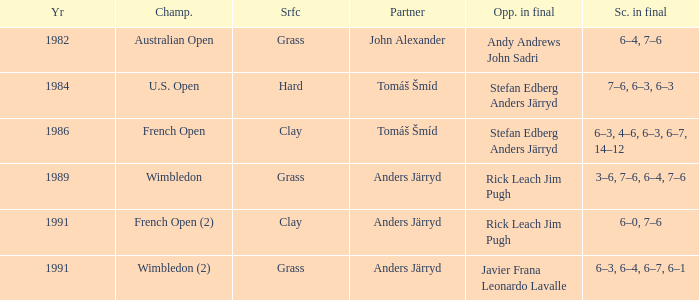What was the final score in 1986? 6–3, 4–6, 6–3, 6–7, 14–12. 